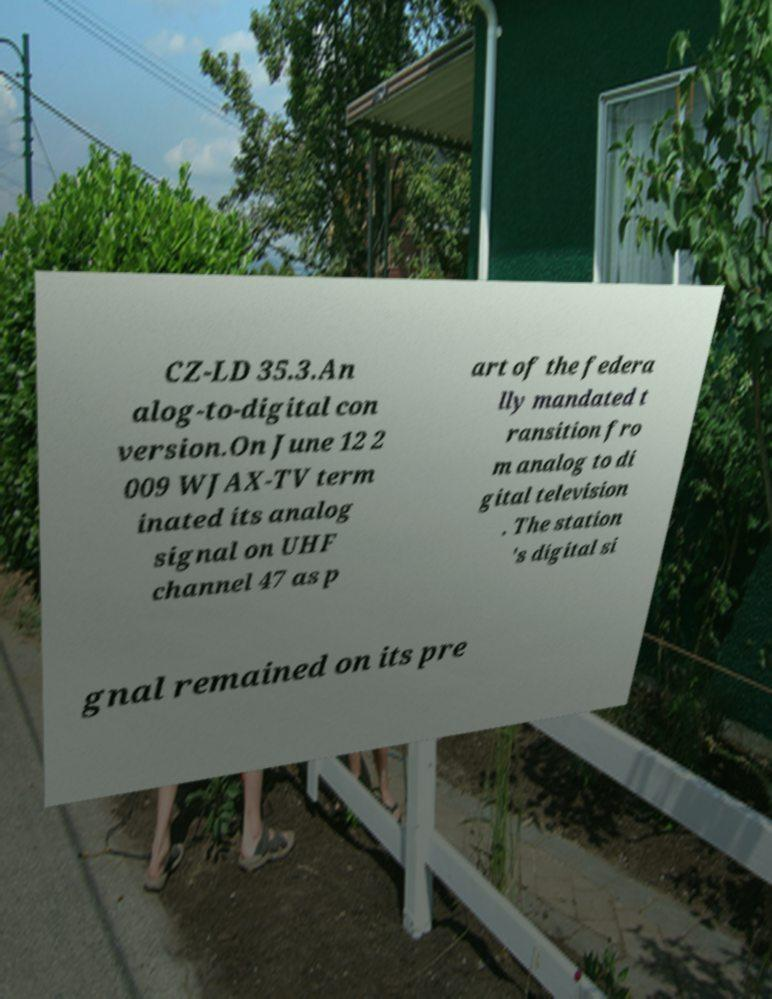There's text embedded in this image that I need extracted. Can you transcribe it verbatim? CZ-LD 35.3.An alog-to-digital con version.On June 12 2 009 WJAX-TV term inated its analog signal on UHF channel 47 as p art of the federa lly mandated t ransition fro m analog to di gital television . The station 's digital si gnal remained on its pre 